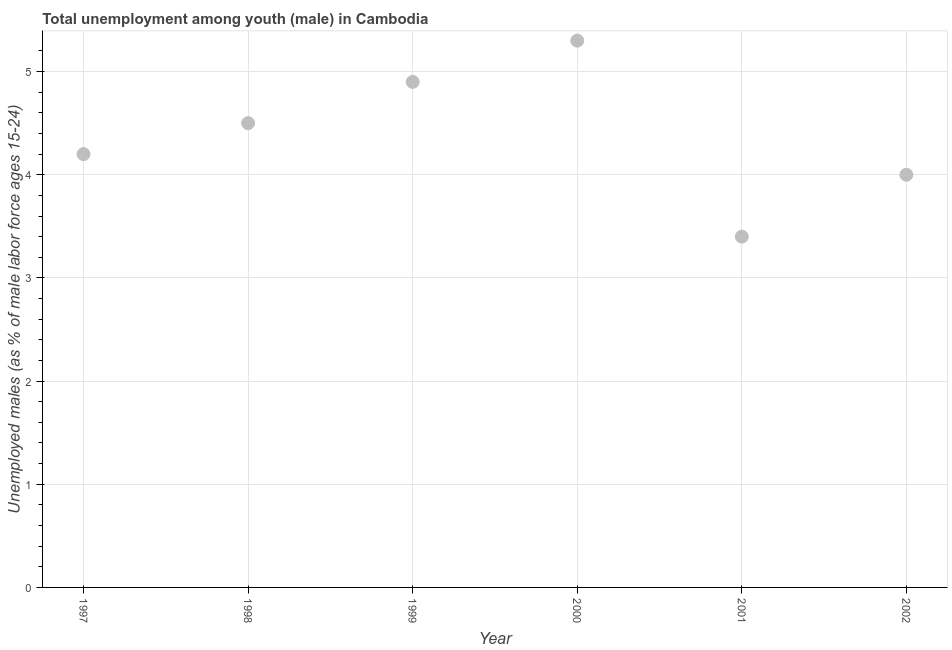What is the unemployed male youth population in 2001?
Your answer should be compact. 3.4. Across all years, what is the maximum unemployed male youth population?
Your response must be concise. 5.3. Across all years, what is the minimum unemployed male youth population?
Ensure brevity in your answer.  3.4. In which year was the unemployed male youth population minimum?
Ensure brevity in your answer.  2001. What is the sum of the unemployed male youth population?
Your answer should be very brief. 26.3. What is the difference between the unemployed male youth population in 1998 and 1999?
Give a very brief answer. -0.4. What is the average unemployed male youth population per year?
Give a very brief answer. 4.38. What is the median unemployed male youth population?
Provide a short and direct response. 4.35. In how many years, is the unemployed male youth population greater than 4.8 %?
Keep it short and to the point. 2. What is the difference between the highest and the second highest unemployed male youth population?
Keep it short and to the point. 0.4. Is the sum of the unemployed male youth population in 1998 and 1999 greater than the maximum unemployed male youth population across all years?
Give a very brief answer. Yes. What is the difference between the highest and the lowest unemployed male youth population?
Your answer should be compact. 1.9. Does the unemployed male youth population monotonically increase over the years?
Provide a succinct answer. No. How many dotlines are there?
Your answer should be very brief. 1. How many years are there in the graph?
Your answer should be compact. 6. Does the graph contain grids?
Ensure brevity in your answer.  Yes. What is the title of the graph?
Make the answer very short. Total unemployment among youth (male) in Cambodia. What is the label or title of the Y-axis?
Offer a very short reply. Unemployed males (as % of male labor force ages 15-24). What is the Unemployed males (as % of male labor force ages 15-24) in 1997?
Your response must be concise. 4.2. What is the Unemployed males (as % of male labor force ages 15-24) in 1998?
Provide a succinct answer. 4.5. What is the Unemployed males (as % of male labor force ages 15-24) in 1999?
Offer a very short reply. 4.9. What is the Unemployed males (as % of male labor force ages 15-24) in 2000?
Offer a terse response. 5.3. What is the Unemployed males (as % of male labor force ages 15-24) in 2001?
Provide a short and direct response. 3.4. What is the difference between the Unemployed males (as % of male labor force ages 15-24) in 1997 and 1998?
Make the answer very short. -0.3. What is the difference between the Unemployed males (as % of male labor force ages 15-24) in 1997 and 2002?
Offer a terse response. 0.2. What is the difference between the Unemployed males (as % of male labor force ages 15-24) in 1998 and 2001?
Keep it short and to the point. 1.1. What is the difference between the Unemployed males (as % of male labor force ages 15-24) in 1999 and 2001?
Your response must be concise. 1.5. What is the difference between the Unemployed males (as % of male labor force ages 15-24) in 2000 and 2001?
Give a very brief answer. 1.9. What is the difference between the Unemployed males (as % of male labor force ages 15-24) in 2000 and 2002?
Keep it short and to the point. 1.3. What is the difference between the Unemployed males (as % of male labor force ages 15-24) in 2001 and 2002?
Keep it short and to the point. -0.6. What is the ratio of the Unemployed males (as % of male labor force ages 15-24) in 1997 to that in 1998?
Offer a very short reply. 0.93. What is the ratio of the Unemployed males (as % of male labor force ages 15-24) in 1997 to that in 1999?
Make the answer very short. 0.86. What is the ratio of the Unemployed males (as % of male labor force ages 15-24) in 1997 to that in 2000?
Provide a short and direct response. 0.79. What is the ratio of the Unemployed males (as % of male labor force ages 15-24) in 1997 to that in 2001?
Your response must be concise. 1.24. What is the ratio of the Unemployed males (as % of male labor force ages 15-24) in 1998 to that in 1999?
Your answer should be very brief. 0.92. What is the ratio of the Unemployed males (as % of male labor force ages 15-24) in 1998 to that in 2000?
Offer a terse response. 0.85. What is the ratio of the Unemployed males (as % of male labor force ages 15-24) in 1998 to that in 2001?
Offer a very short reply. 1.32. What is the ratio of the Unemployed males (as % of male labor force ages 15-24) in 1998 to that in 2002?
Offer a very short reply. 1.12. What is the ratio of the Unemployed males (as % of male labor force ages 15-24) in 1999 to that in 2000?
Ensure brevity in your answer.  0.93. What is the ratio of the Unemployed males (as % of male labor force ages 15-24) in 1999 to that in 2001?
Offer a terse response. 1.44. What is the ratio of the Unemployed males (as % of male labor force ages 15-24) in 1999 to that in 2002?
Ensure brevity in your answer.  1.23. What is the ratio of the Unemployed males (as % of male labor force ages 15-24) in 2000 to that in 2001?
Keep it short and to the point. 1.56. What is the ratio of the Unemployed males (as % of male labor force ages 15-24) in 2000 to that in 2002?
Give a very brief answer. 1.32. 